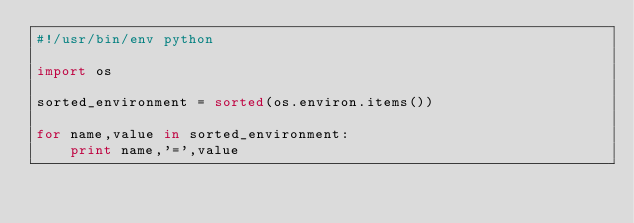Convert code to text. <code><loc_0><loc_0><loc_500><loc_500><_Python_>#!/usr/bin/env python

import os

sorted_environment = sorted(os.environ.items())

for name,value in sorted_environment:
    print name,'=',value
</code> 